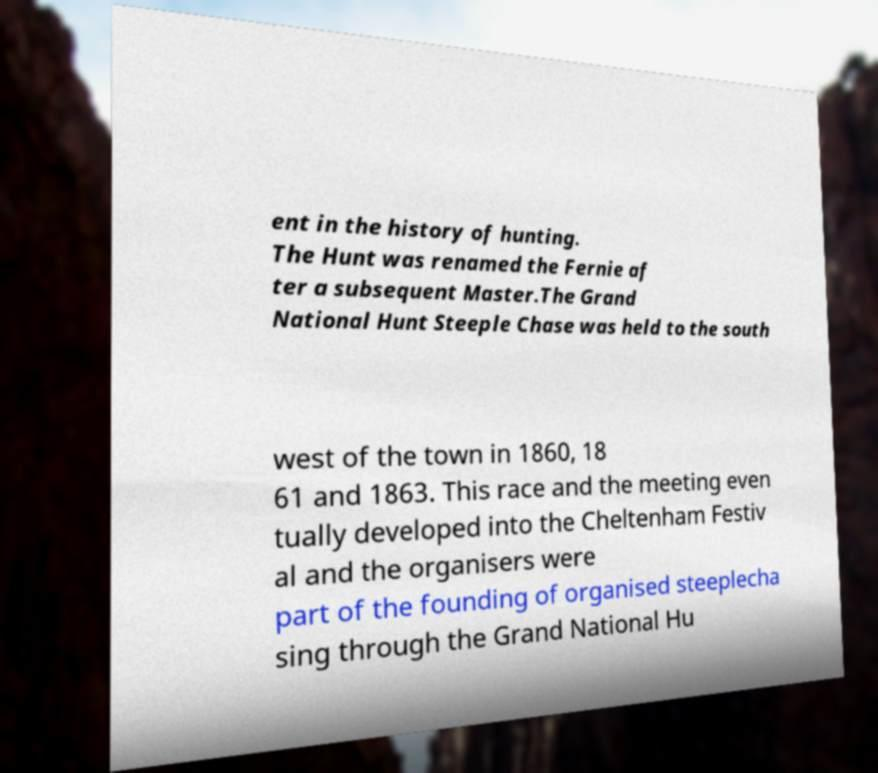Could you extract and type out the text from this image? ent in the history of hunting. The Hunt was renamed the Fernie af ter a subsequent Master.The Grand National Hunt Steeple Chase was held to the south west of the town in 1860, 18 61 and 1863. This race and the meeting even tually developed into the Cheltenham Festiv al and the organisers were part of the founding of organised steeplecha sing through the Grand National Hu 